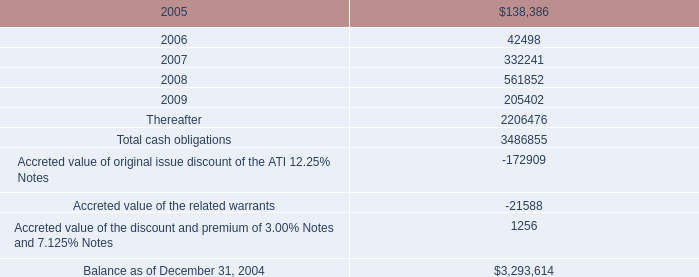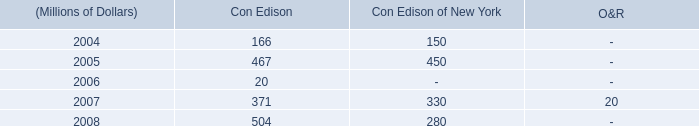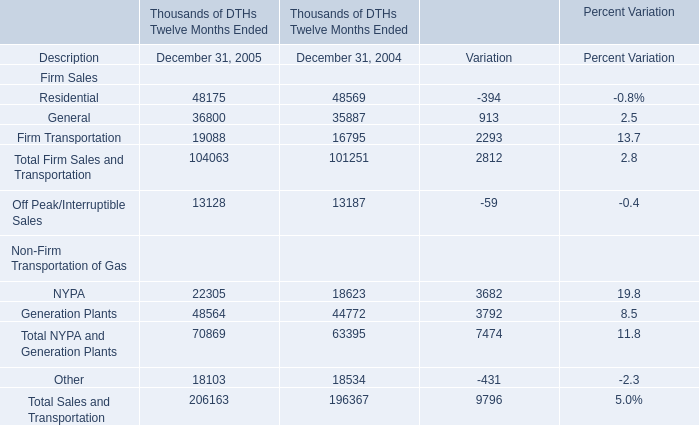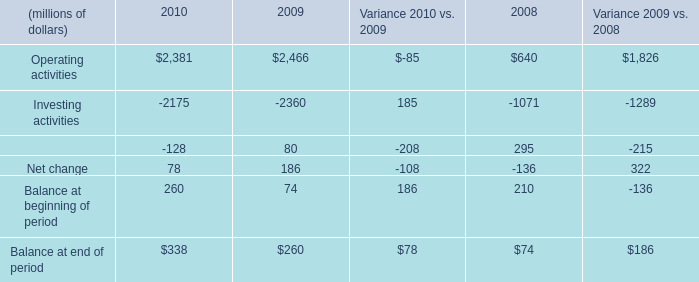Does the value of residential in 2005 greater than that in 2004 ? 
Answer: NO. 